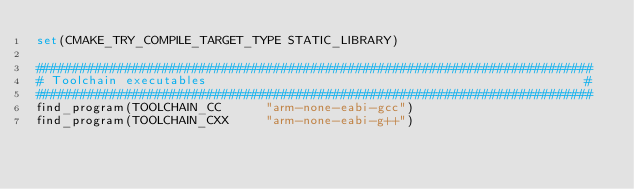<code> <loc_0><loc_0><loc_500><loc_500><_CMake_>set(CMAKE_TRY_COMPILE_TARGET_TYPE STATIC_LIBRARY)

###########################################################################
# Toolchain executables                                                   #
###########################################################################
find_program(TOOLCHAIN_CC      "arm-none-eabi-gcc")
find_program(TOOLCHAIN_CXX     "arm-none-eabi-g++")</code> 